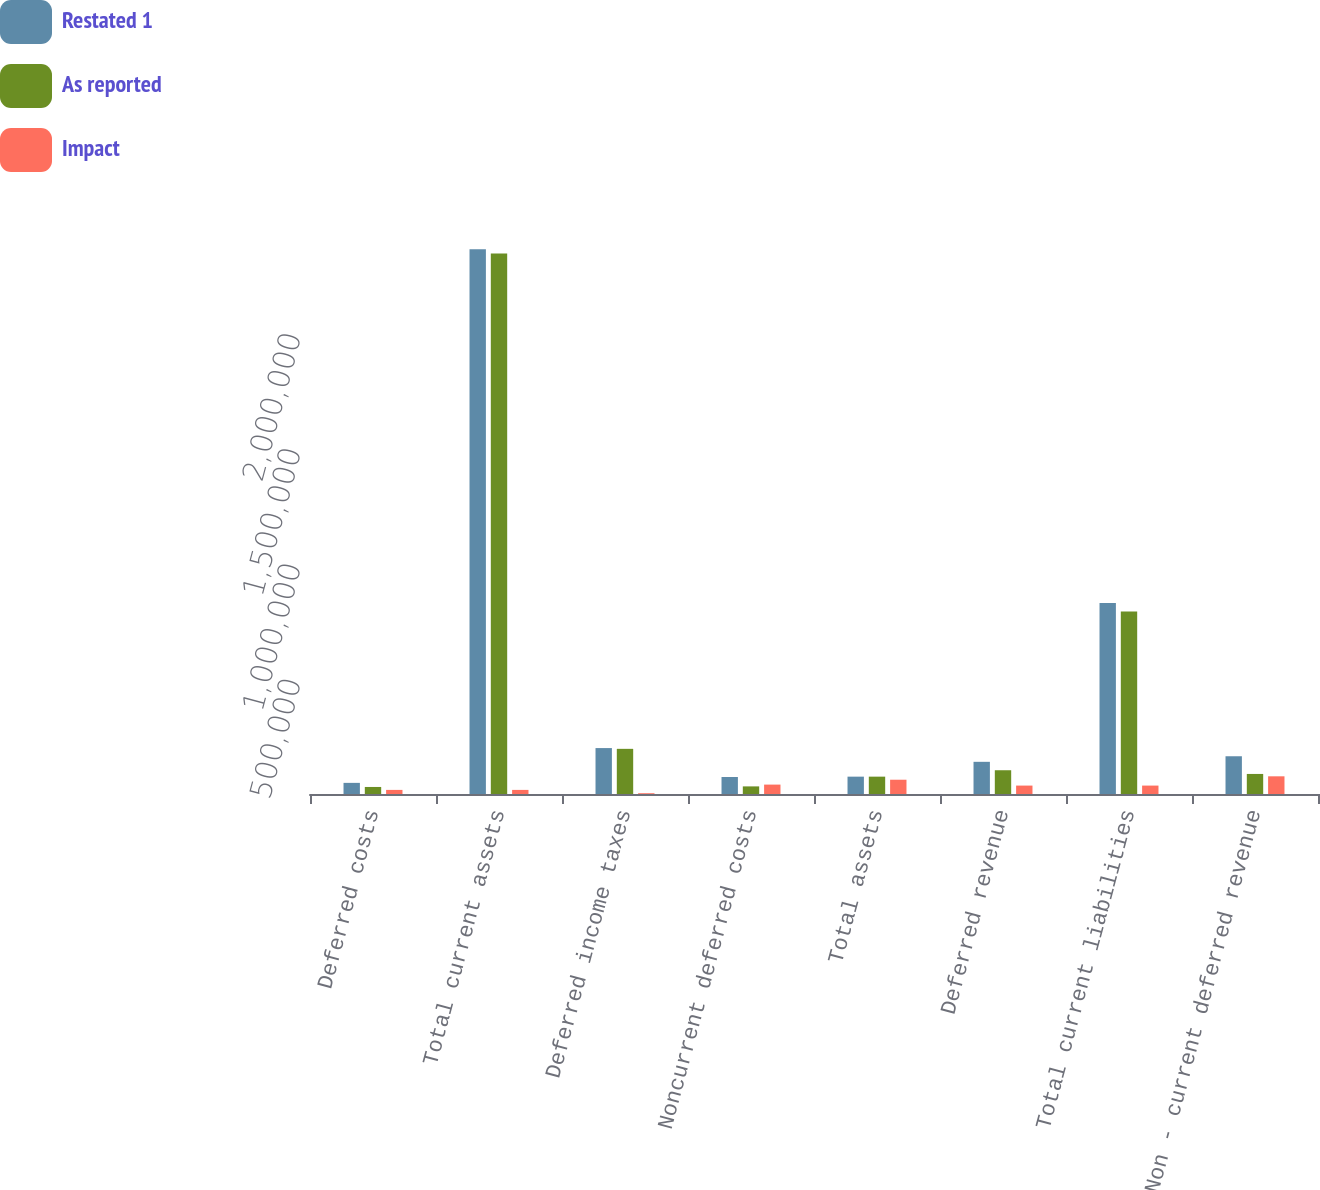Convert chart. <chart><loc_0><loc_0><loc_500><loc_500><stacked_bar_chart><ecel><fcel>Deferred costs<fcel>Total current assets<fcel>Deferred income taxes<fcel>Noncurrent deferred costs<fcel>Total assets<fcel>Deferred revenue<fcel>Total current liabilities<fcel>Non - current deferred revenue<nl><fcel>Restated 1<fcel>48312<fcel>2.36392e+06<fcel>199343<fcel>73851<fcel>75315.5<fcel>139681<fcel>828656<fcel>163840<nl><fcel>As reported<fcel>30525<fcel>2.34614e+06<fcel>195981<fcel>33029<fcel>75315.5<fcel>103140<fcel>792115<fcel>87060<nl><fcel>Impact<fcel>17787<fcel>17787<fcel>3362<fcel>40822<fcel>61971<fcel>36541<fcel>36541<fcel>76780<nl></chart> 